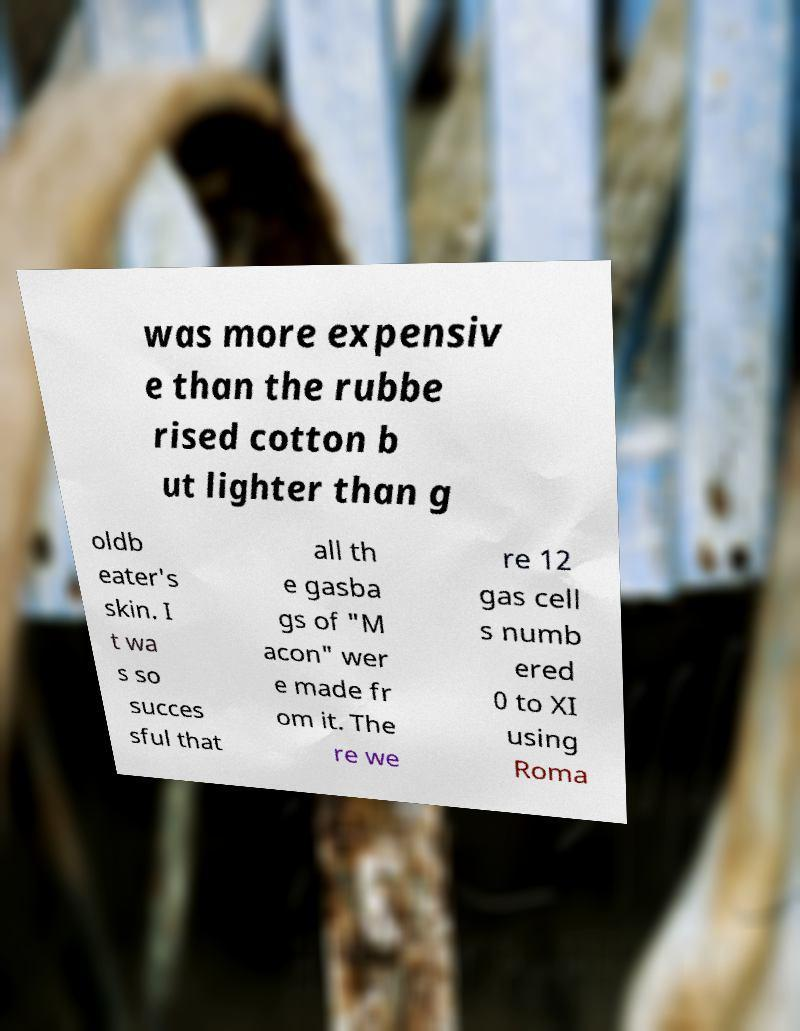Could you assist in decoding the text presented in this image and type it out clearly? was more expensiv e than the rubbe rised cotton b ut lighter than g oldb eater's skin. I t wa s so succes sful that all th e gasba gs of "M acon" wer e made fr om it. The re we re 12 gas cell s numb ered 0 to XI using Roma 